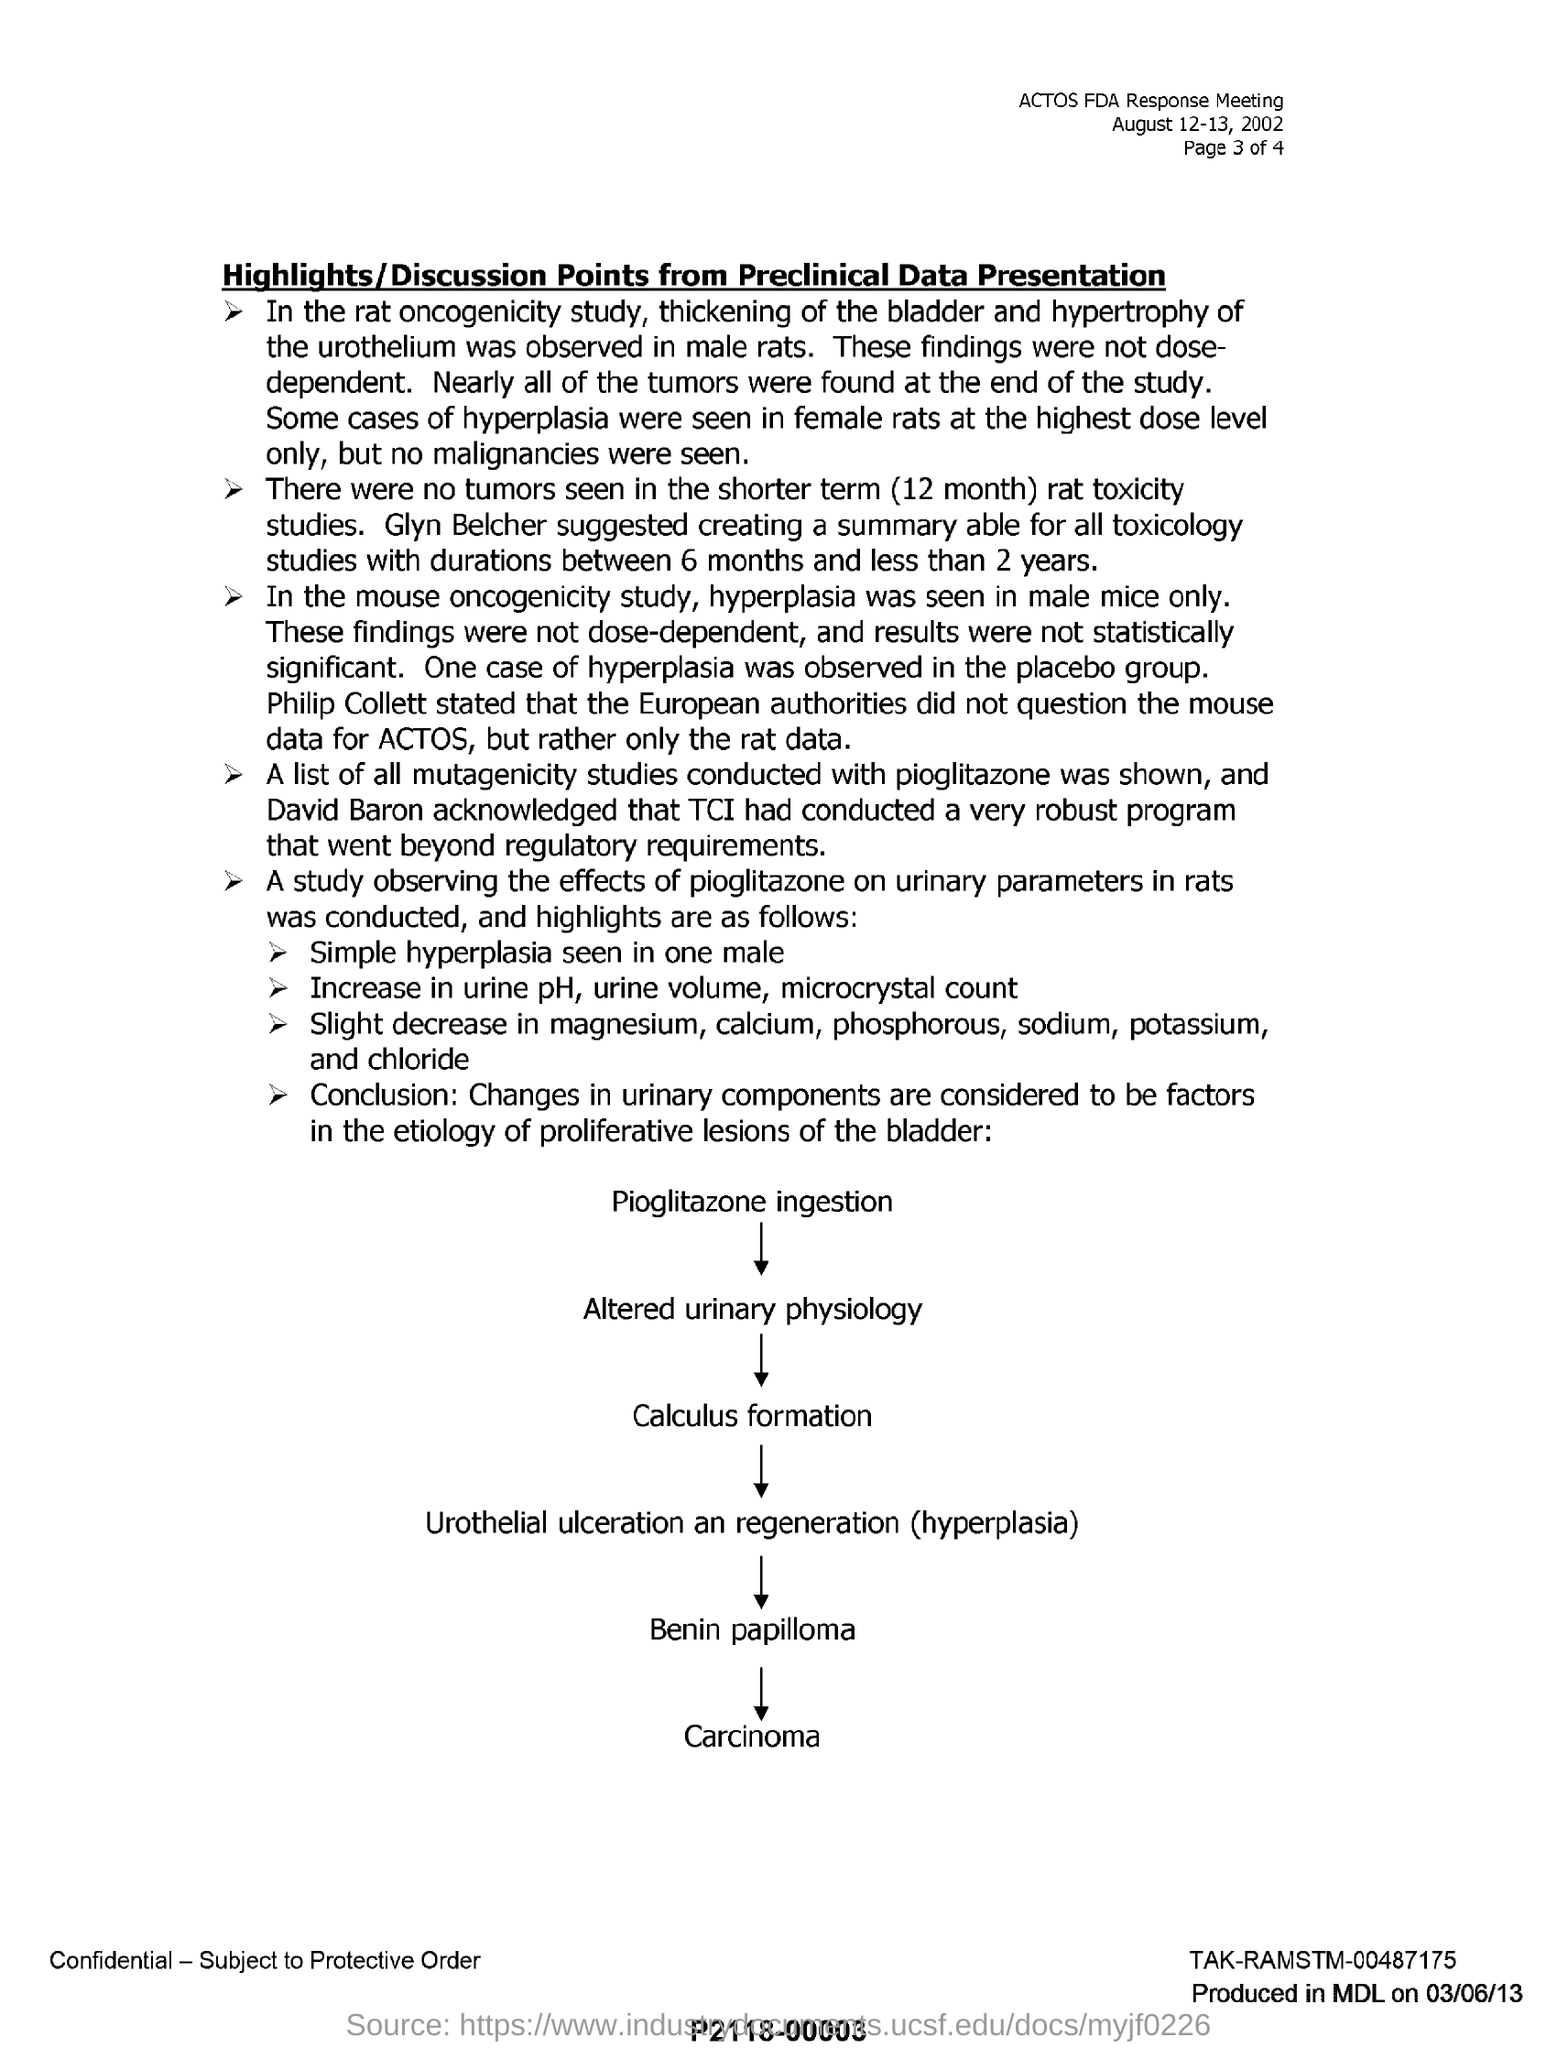Point out several critical features in this image. In a rat oncogenicity study, male rats were observed to have thickened bladders and enlarged urotheliums, indicating the potential for bladder cancer development. In a study examining the oncogenicity of mice, male mice were found to have hyperplasia in specific tissues, but not in female mice. The TCI conducted a robust program. The time span in which no tumors are observed is a shorter term of 12 months. 